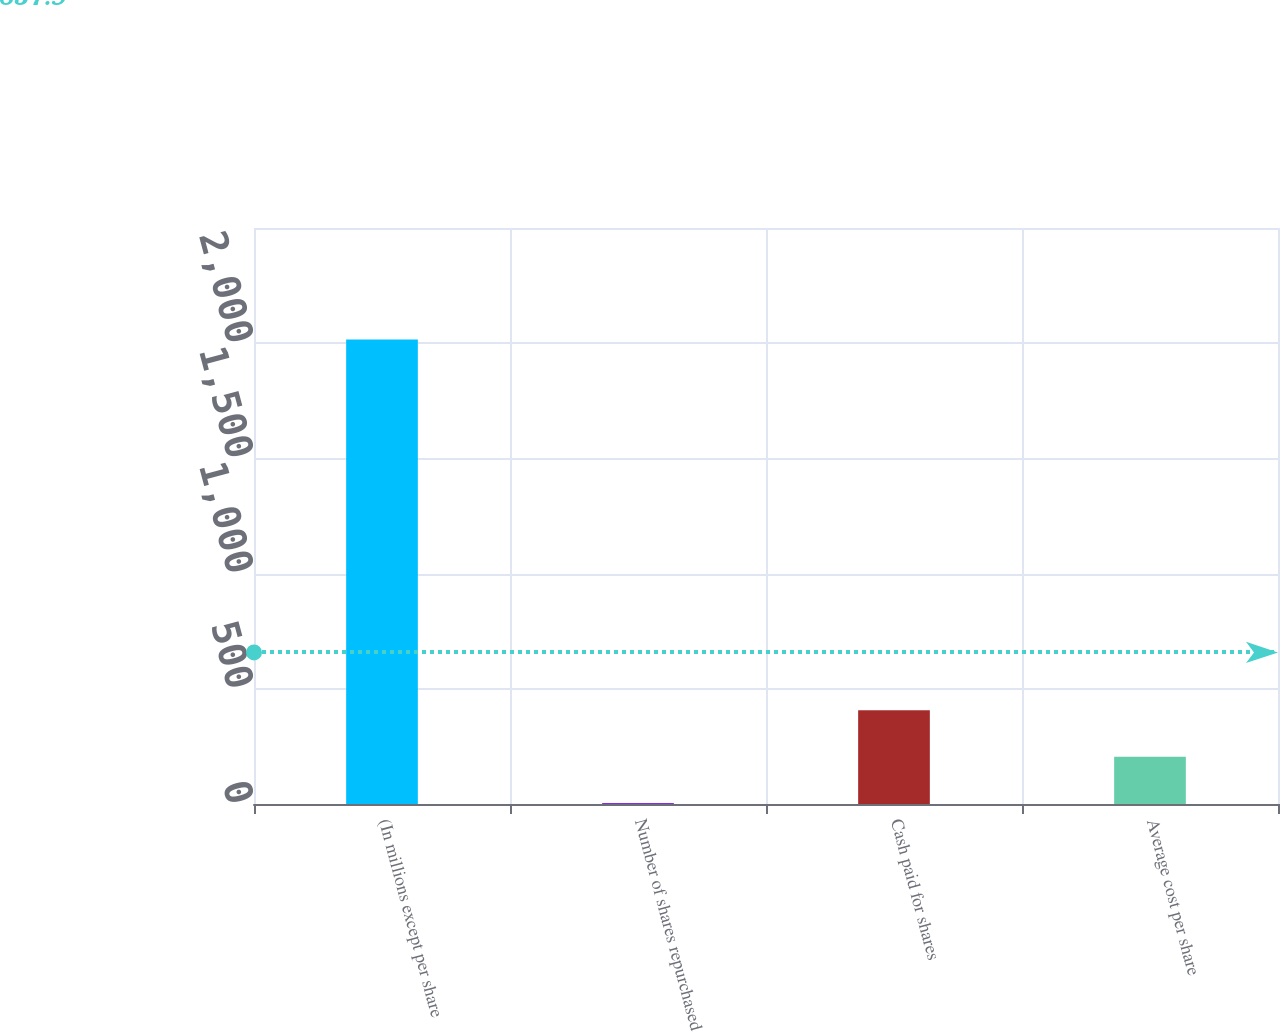Convert chart. <chart><loc_0><loc_0><loc_500><loc_500><bar_chart><fcel>(In millions except per share<fcel>Number of shares repurchased<fcel>Cash paid for shares<fcel>Average cost per share<nl><fcel>2016<fcel>4<fcel>406.4<fcel>205.2<nl></chart> 